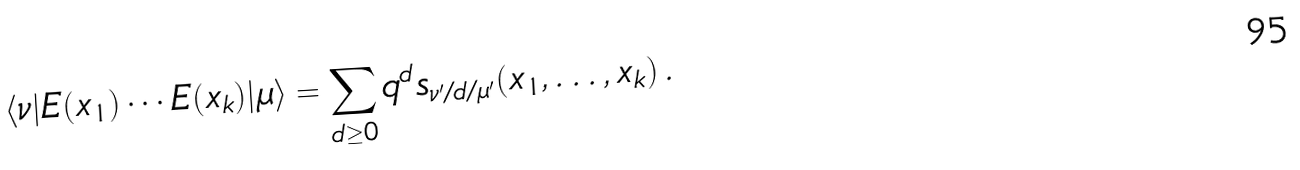<formula> <loc_0><loc_0><loc_500><loc_500>\langle \nu | E ( x _ { 1 } ) \cdots E ( x _ { k } ) | \mu \rangle = \sum _ { d \geq 0 } q ^ { d } s _ { \nu ^ { \prime } / d / \mu ^ { \prime } } ( x _ { 1 } , \dots , x _ { k } ) \, .</formula> 